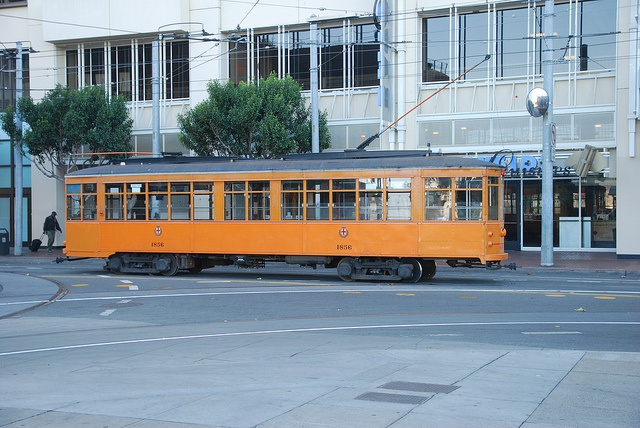Describe the objects in this image and their specific colors. I can see train in black, orange, and gray tones, bus in black, orange, and gray tones, people in black, blue, gray, and darkblue tones, people in black, gray, and blue tones, and suitcase in black, darkgray, and gray tones in this image. 